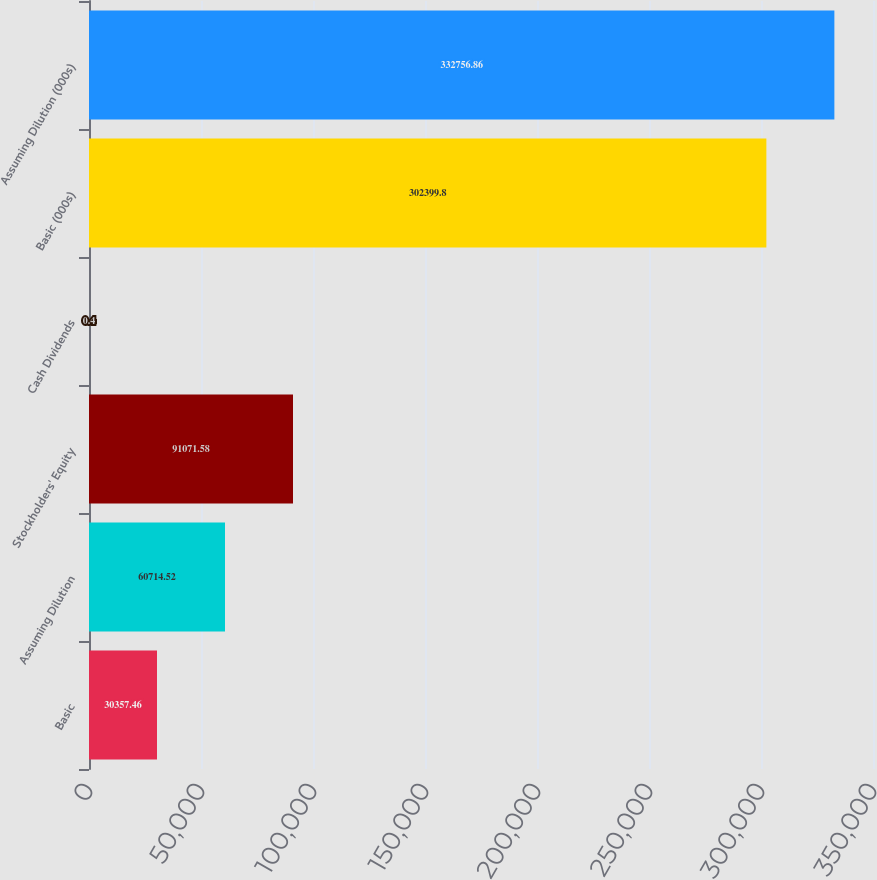<chart> <loc_0><loc_0><loc_500><loc_500><bar_chart><fcel>Basic<fcel>Assuming Dilution<fcel>Stockholders' Equity<fcel>Cash Dividends<fcel>Basic (000s)<fcel>Assuming Dilution (000s)<nl><fcel>30357.5<fcel>60714.5<fcel>91071.6<fcel>0.4<fcel>302400<fcel>332757<nl></chart> 